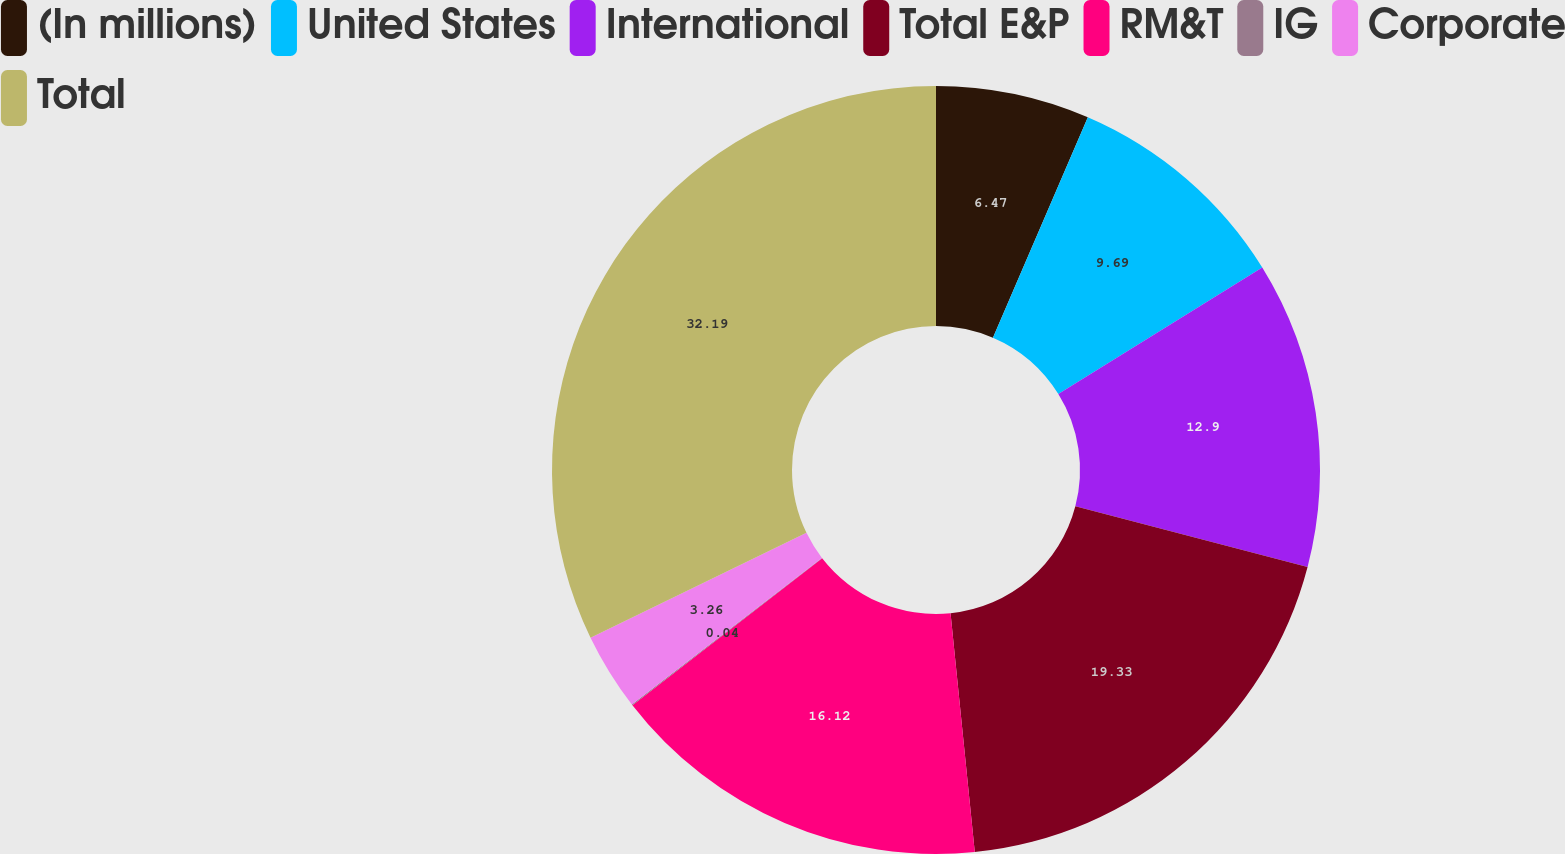Convert chart to OTSL. <chart><loc_0><loc_0><loc_500><loc_500><pie_chart><fcel>(In millions)<fcel>United States<fcel>International<fcel>Total E&P<fcel>RM&T<fcel>IG<fcel>Corporate<fcel>Total<nl><fcel>6.47%<fcel>9.69%<fcel>12.9%<fcel>19.33%<fcel>16.12%<fcel>0.04%<fcel>3.26%<fcel>32.19%<nl></chart> 